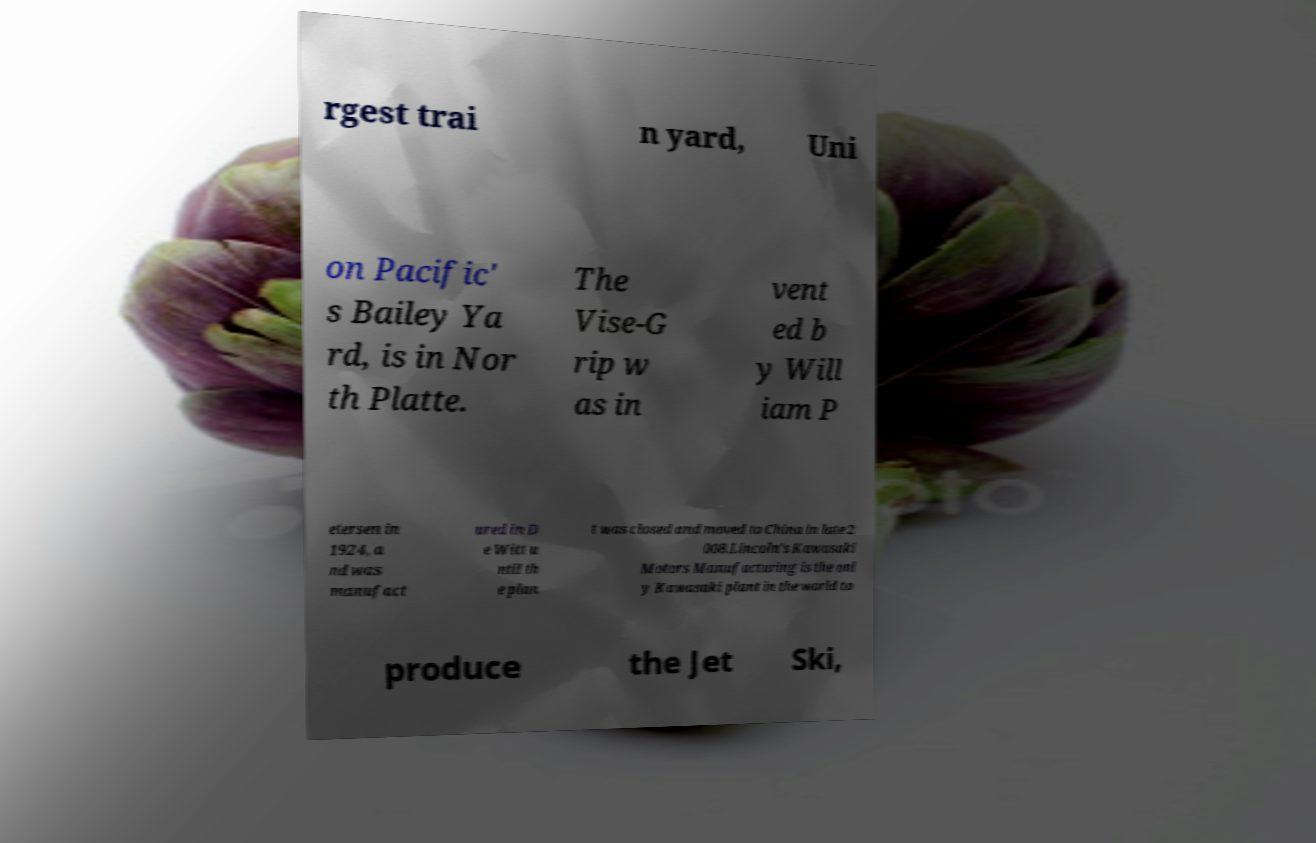What messages or text are displayed in this image? I need them in a readable, typed format. rgest trai n yard, Uni on Pacific' s Bailey Ya rd, is in Nor th Platte. The Vise-G rip w as in vent ed b y Will iam P etersen in 1924, a nd was manufact ured in D e Witt u ntil th e plan t was closed and moved to China in late 2 008.Lincoln's Kawasaki Motors Manufacturing is the onl y Kawasaki plant in the world to produce the Jet Ski, 